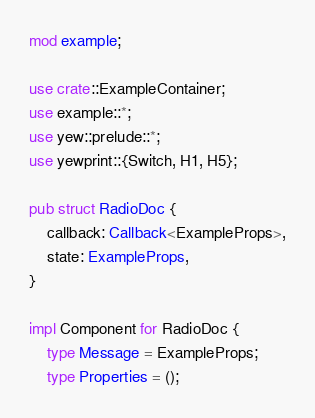Convert code to text. <code><loc_0><loc_0><loc_500><loc_500><_Rust_>mod example;

use crate::ExampleContainer;
use example::*;
use yew::prelude::*;
use yewprint::{Switch, H1, H5};

pub struct RadioDoc {
    callback: Callback<ExampleProps>,
    state: ExampleProps,
}

impl Component for RadioDoc {
    type Message = ExampleProps;
    type Properties = ();
</code> 